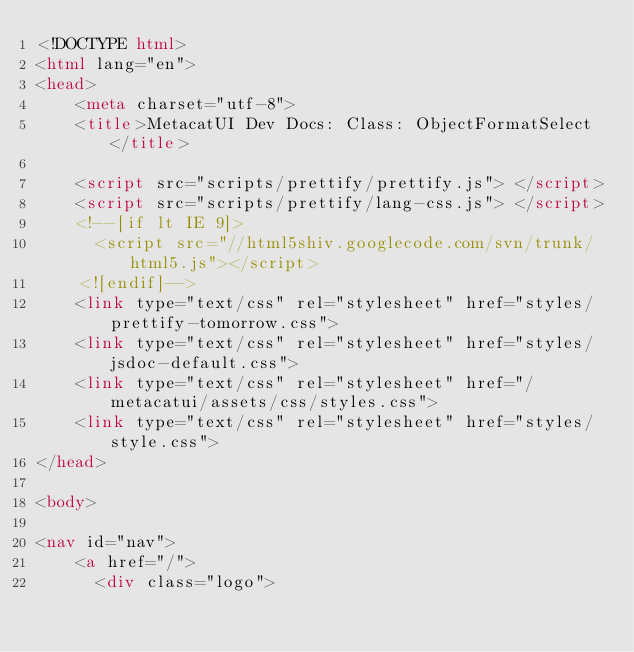<code> <loc_0><loc_0><loc_500><loc_500><_HTML_><!DOCTYPE html>
<html lang="en">
<head>
    <meta charset="utf-8">
    <title>MetacatUI Dev Docs: Class: ObjectFormatSelect</title>

    <script src="scripts/prettify/prettify.js"> </script>
    <script src="scripts/prettify/lang-css.js"> </script>
    <!--[if lt IE 9]>
      <script src="//html5shiv.googlecode.com/svn/trunk/html5.js"></script>
    <![endif]-->
    <link type="text/css" rel="stylesheet" href="styles/prettify-tomorrow.css">
    <link type="text/css" rel="stylesheet" href="styles/jsdoc-default.css">
    <link type="text/css" rel="stylesheet" href="/metacatui/assets/css/styles.css">
    <link type="text/css" rel="stylesheet" href="styles/style.css">
</head>

<body>

<nav id="nav">
    <a href="/">
      <div class="logo"></code> 